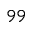Convert formula to latex. <formula><loc_0><loc_0><loc_500><loc_500>^ { 9 9 }</formula> 